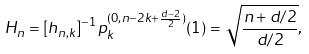<formula> <loc_0><loc_0><loc_500><loc_500>H _ { n } = [ h _ { n , k } ] ^ { - 1 } p _ { k } ^ { ( 0 , n - 2 k + \frac { d - 2 } { 2 } ) } ( 1 ) = \sqrt { \frac { n + d / 2 } { d / 2 } } ,</formula> 